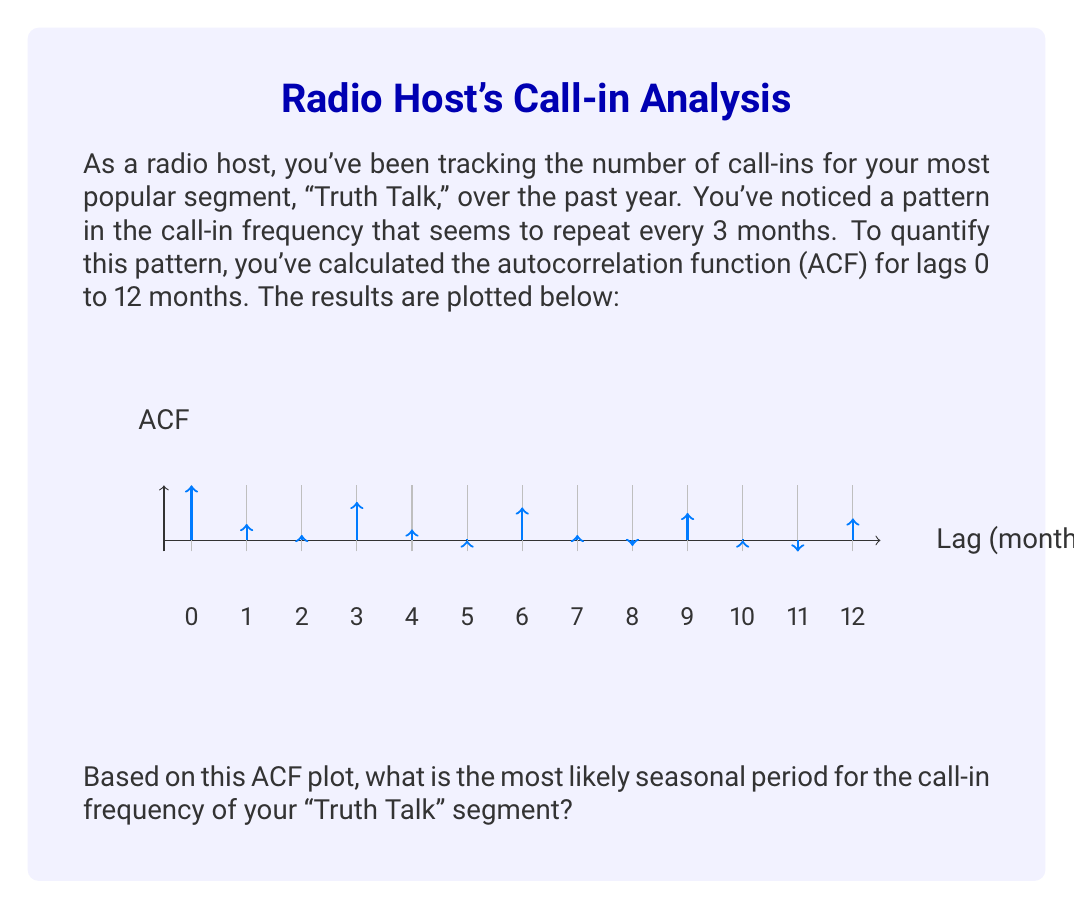Teach me how to tackle this problem. To determine the seasonal pattern from an ACF plot, we need to look for repeating peaks at regular intervals. Here's how we can analyze this plot:

1. The ACF at lag 0 is always 1, as it represents the correlation of the series with itself.

2. We observe significant peaks (values close to 1) at the following lags:
   - Lag 3: ACF ≈ 0.7
   - Lag 6: ACF ≈ 0.6
   - Lag 9: ACF ≈ 0.5
   - Lag 12: ACF ≈ 0.4

3. The pattern of peaks repeats every 3 lags (3, 6, 9, 12).

4. In time series analysis, the seasonal period is typically identified by the lag at which the first significant peak occurs after lag 0.

5. In this case, the first significant peak after lag 0 occurs at lag 3.

6. The repeating pattern every 3 lags further confirms this seasonal period.

Therefore, the most likely seasonal period for the call-in frequency is 3 months. This means the pattern of call-ins tends to repeat every quarter, which could be due to factors such as changing seasons, recurring events, or the structure of your radio show.
Answer: 3 months 